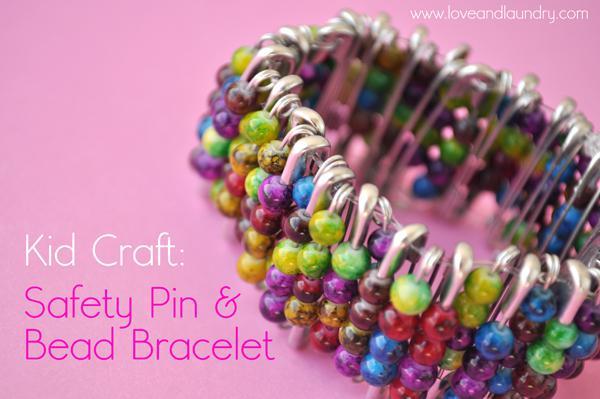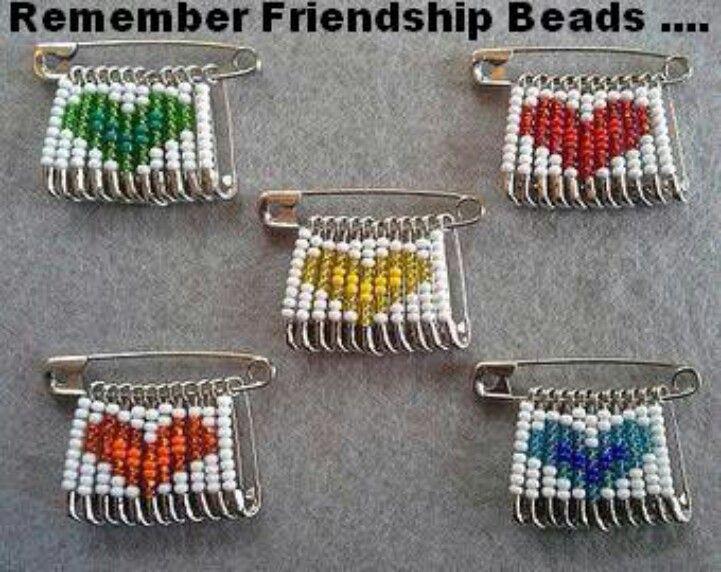The first image is the image on the left, the second image is the image on the right. Given the left and right images, does the statement "An image includes a safety pin with a row of beaded pins suspended, which create a recognizable pattern." hold true? Answer yes or no. Yes. The first image is the image on the left, the second image is the image on the right. Analyze the images presented: Is the assertion "In one of the images there is a group of beaded safety pins that reveal a particular shape." valid? Answer yes or no. Yes. 